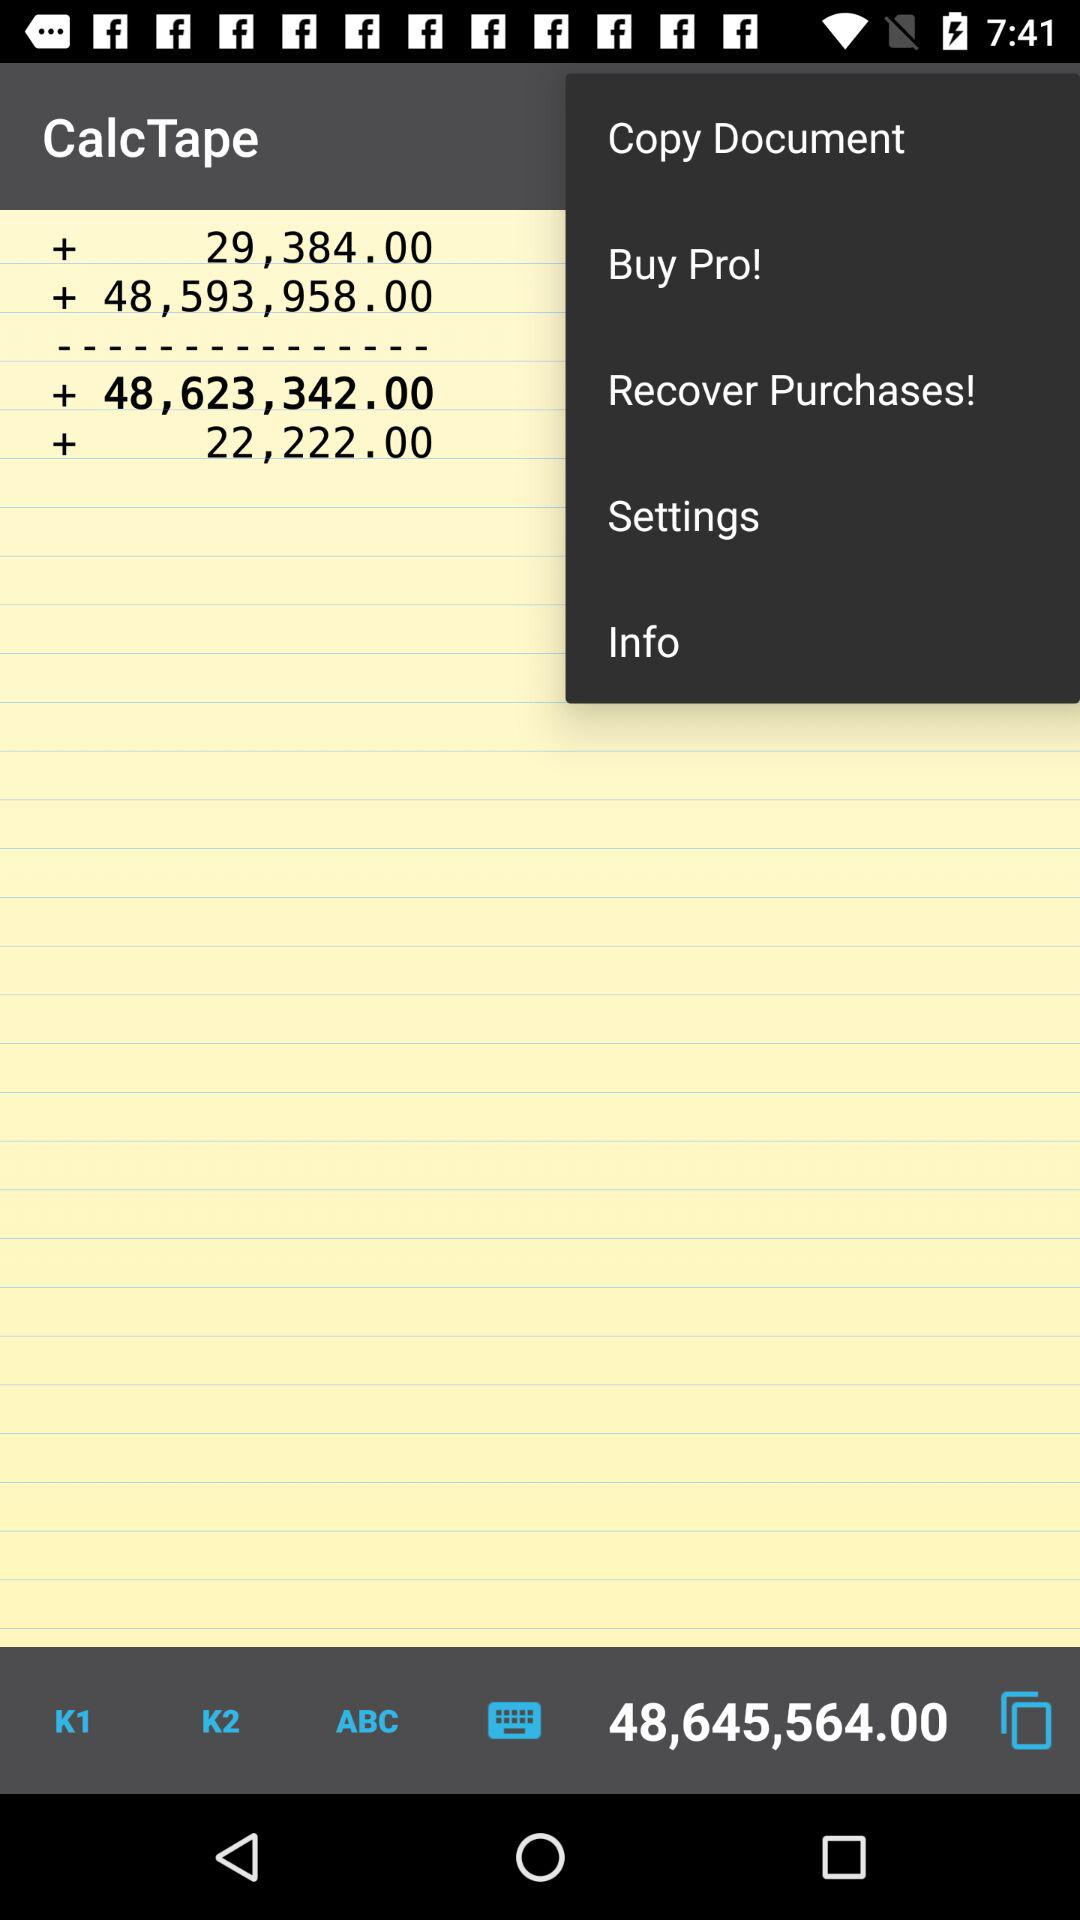How many notifications are there in "Settings"?
When the provided information is insufficient, respond with <no answer>. <no answer> 